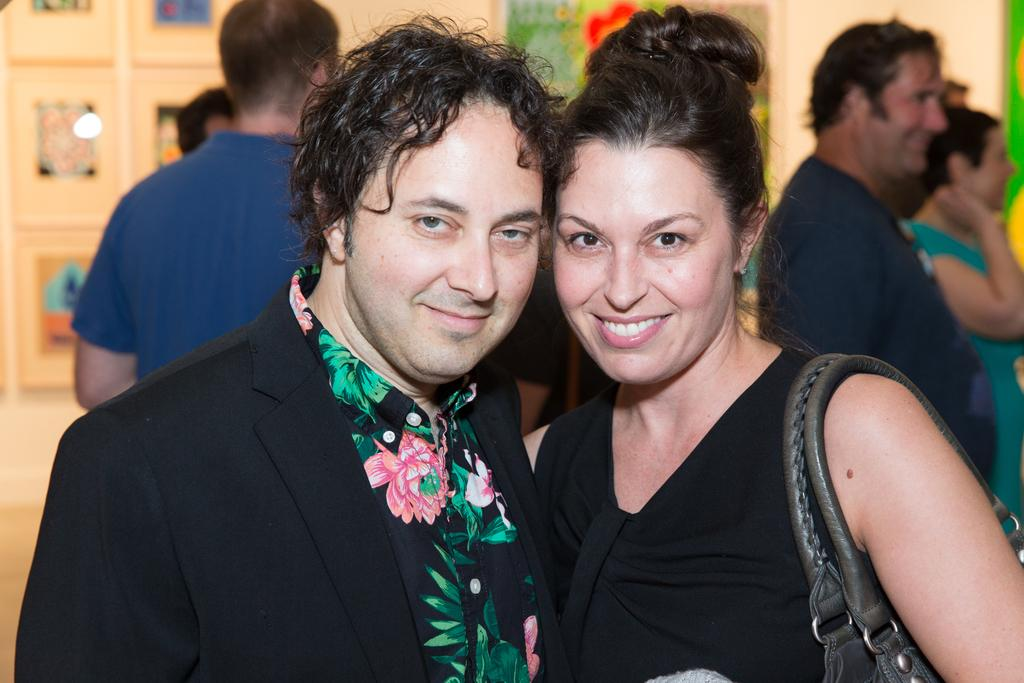How many people are present in the image? There are two people in the image, a man and a woman. What are the man and the woman wearing? Both the man and the woman are wearing black dresses. What is the woman holding in the image? The woman is holding a bag. Can you describe the background of the image? There are a few people in the background of the image. What type of lumber is being traded in the image? There is no mention of lumber or trade in the image; it features a man and a woman wearing black dresses, with the woman holding a bag. 